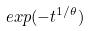Convert formula to latex. <formula><loc_0><loc_0><loc_500><loc_500>e x p ( - t ^ { 1 / \theta } )</formula> 